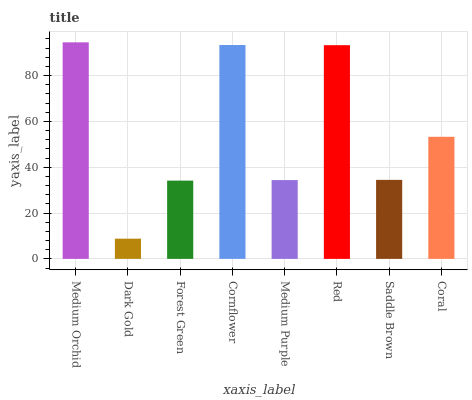Is Dark Gold the minimum?
Answer yes or no. Yes. Is Medium Orchid the maximum?
Answer yes or no. Yes. Is Forest Green the minimum?
Answer yes or no. No. Is Forest Green the maximum?
Answer yes or no. No. Is Forest Green greater than Dark Gold?
Answer yes or no. Yes. Is Dark Gold less than Forest Green?
Answer yes or no. Yes. Is Dark Gold greater than Forest Green?
Answer yes or no. No. Is Forest Green less than Dark Gold?
Answer yes or no. No. Is Coral the high median?
Answer yes or no. Yes. Is Saddle Brown the low median?
Answer yes or no. Yes. Is Dark Gold the high median?
Answer yes or no. No. Is Forest Green the low median?
Answer yes or no. No. 